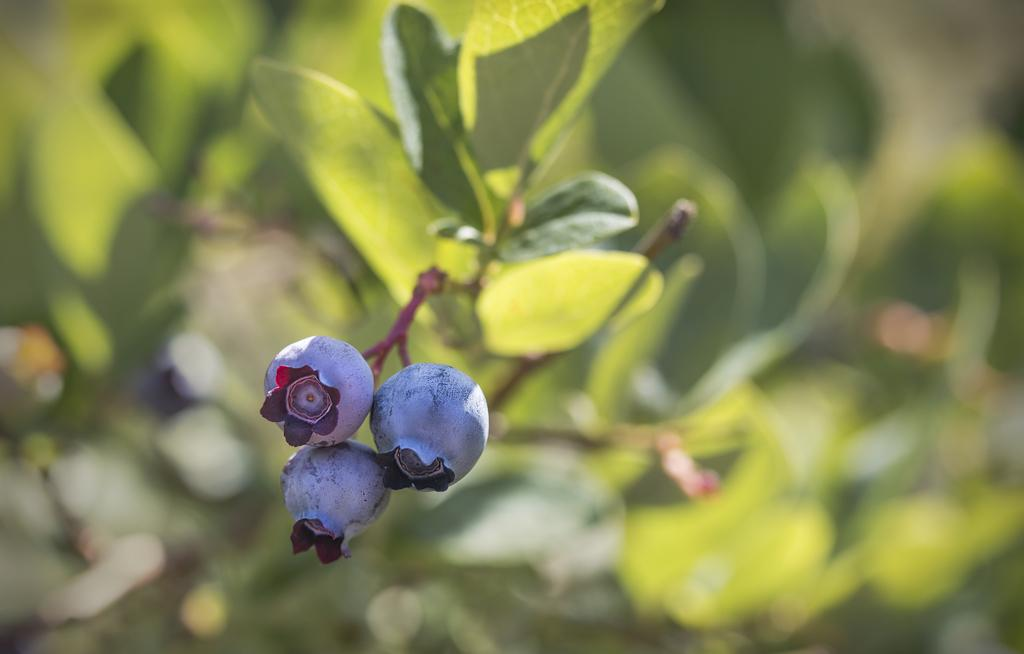What is present in the image besides the blueberry fruits? There is a plant in the image. How many blueberry fruits can be seen in the image? There are three blueberry fruits in the image. What can be observed about the background of the image? The background of the image is blurred. What type of gun is visible in the image? There is no gun present in the image; it features a plant and blueberry fruits. How does the dirt appear on the plant in the image? There is no dirt visible on the plant in the image. 